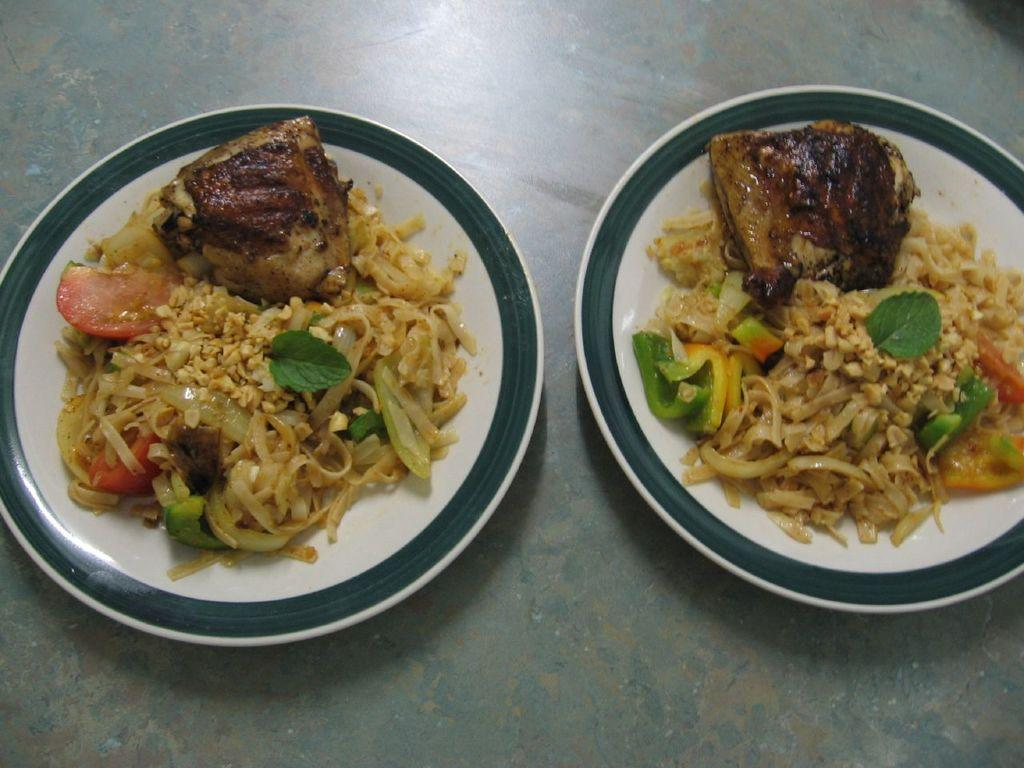What type of food is visible in the image? There are noodles and meat in the image. How are the noodles and meat arranged in the image? The noodles and meat are on plates in the image. Where are the plates with noodles and meat located? The plates are on a table in the image. What type of apparatus is used to cook the noodles and meat in the image? There is no apparatus visible in the image; it only shows the cooked noodles and meat on plates. 